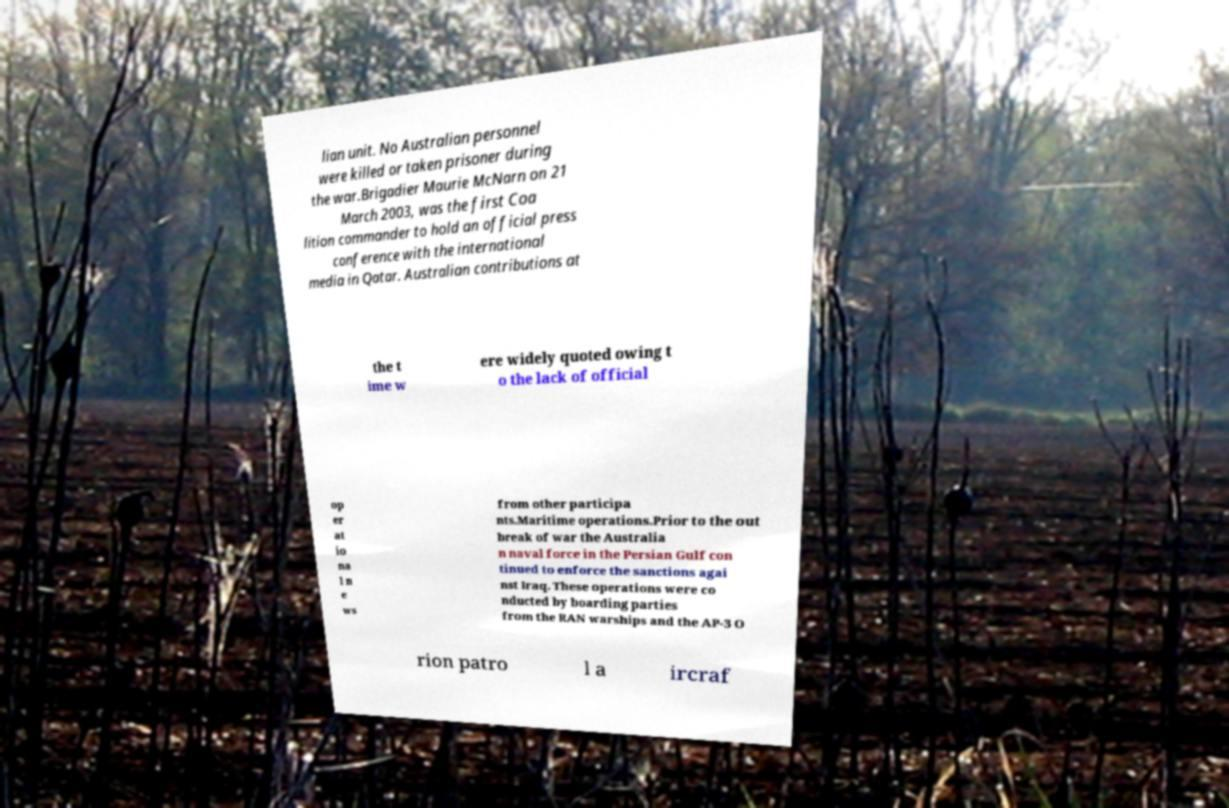Please identify and transcribe the text found in this image. lian unit. No Australian personnel were killed or taken prisoner during the war.Brigadier Maurie McNarn on 21 March 2003, was the first Coa lition commander to hold an official press conference with the international media in Qatar. Australian contributions at the t ime w ere widely quoted owing t o the lack of official op er at io na l n e ws from other participa nts.Maritime operations.Prior to the out break of war the Australia n naval force in the Persian Gulf con tinued to enforce the sanctions agai nst Iraq. These operations were co nducted by boarding parties from the RAN warships and the AP-3 O rion patro l a ircraf 